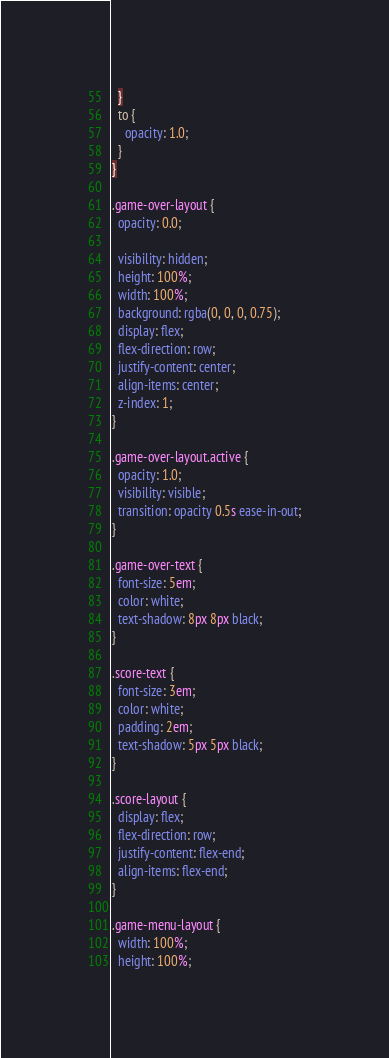<code> <loc_0><loc_0><loc_500><loc_500><_CSS_>  }
  to {
    opacity: 1.0;
  }
}

.game-over-layout {
  opacity: 0.0;

  visibility: hidden;
  height: 100%;
  width: 100%;
  background: rgba(0, 0, 0, 0.75);
  display: flex;
  flex-direction: row;
  justify-content: center;
  align-items: center;
  z-index: 1;
}

.game-over-layout.active {
  opacity: 1.0;
  visibility: visible;
  transition: opacity 0.5s ease-in-out;
}

.game-over-text {
  font-size: 5em;
  color: white;
  text-shadow: 8px 8px black;
}

.score-text {
  font-size: 3em;
  color: white;
  padding: 2em;
  text-shadow: 5px 5px black;
}

.score-layout {
  display: flex;
  flex-direction: row;
  justify-content: flex-end;
  align-items: flex-end;
}

.game-menu-layout {
  width: 100%;
  height: 100%;</code> 